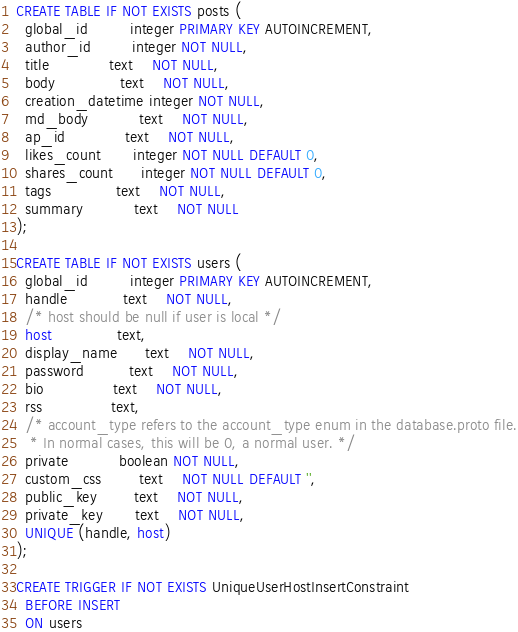<code> <loc_0><loc_0><loc_500><loc_500><_SQL_>CREATE TABLE IF NOT EXISTS posts (
  global_id         integer PRIMARY KEY AUTOINCREMENT,
  author_id         integer NOT NULL,
  title             text    NOT NULL,
  body              text    NOT NULL,
  creation_datetime integer NOT NULL,
  md_body           text    NOT NULL,
  ap_id             text    NOT NULL,
  likes_count       integer NOT NULL DEFAULT 0,
  shares_count      integer NOT NULL DEFAULT 0,
  tags              text    NOT NULL,
  summary           text    NOT NULL
);

CREATE TABLE IF NOT EXISTS users (
  global_id         integer PRIMARY KEY AUTOINCREMENT,
  handle            text    NOT NULL,
  /* host should be null if user is local */
  host              text,
  display_name      text    NOT NULL,
  password          text    NOT NULL,
  bio               text    NOT NULL,
  rss               text,
  /* account_type refers to the account_type enum in the database.proto file.
   * In normal cases, this will be 0, a normal user. */
  private           boolean NOT NULL,
  custom_css        text    NOT NULL DEFAULT '',
  public_key        text    NOT NULL,
  private_key       text    NOT NULL,
  UNIQUE (handle, host)
);

CREATE TRIGGER IF NOT EXISTS UniqueUserHostInsertConstraint
  BEFORE INSERT
  ON users</code> 